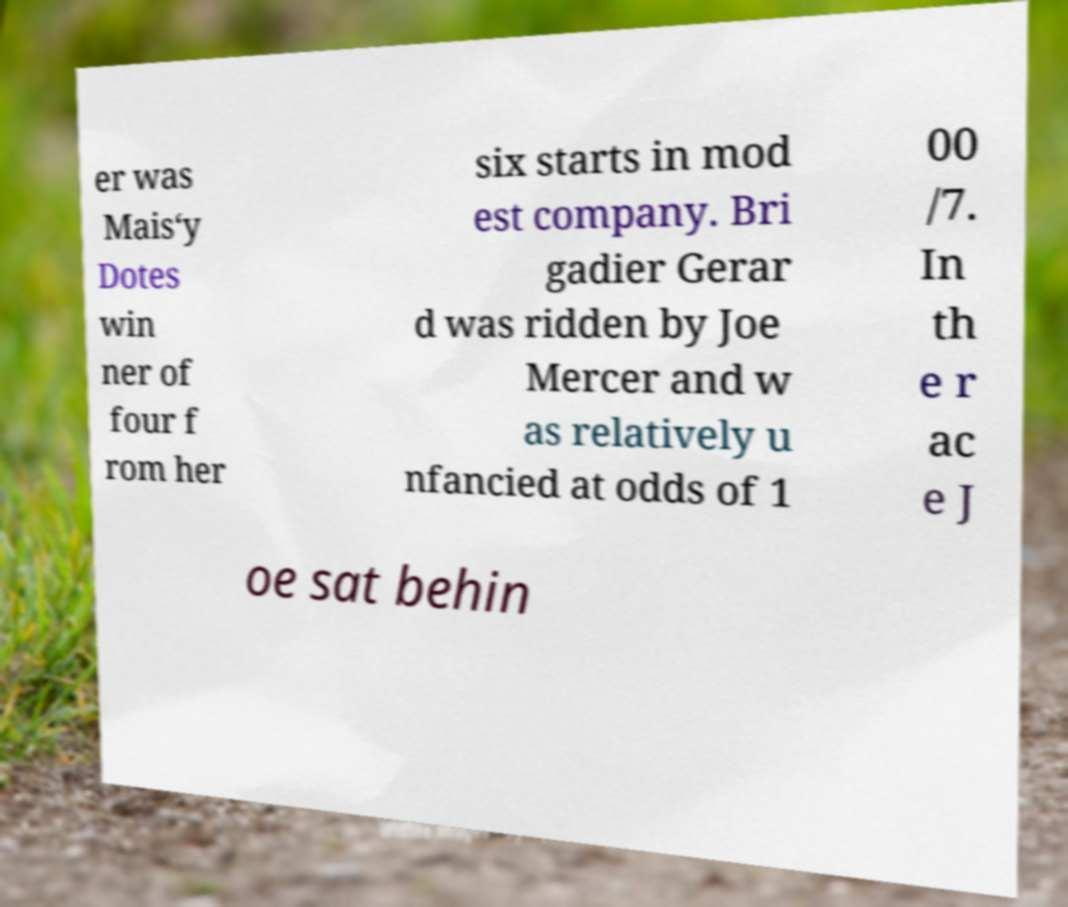I need the written content from this picture converted into text. Can you do that? er was Mais‘y Dotes win ner of four f rom her six starts in mod est company. Bri gadier Gerar d was ridden by Joe Mercer and w as relatively u nfancied at odds of 1 00 /7. In th e r ac e J oe sat behin 